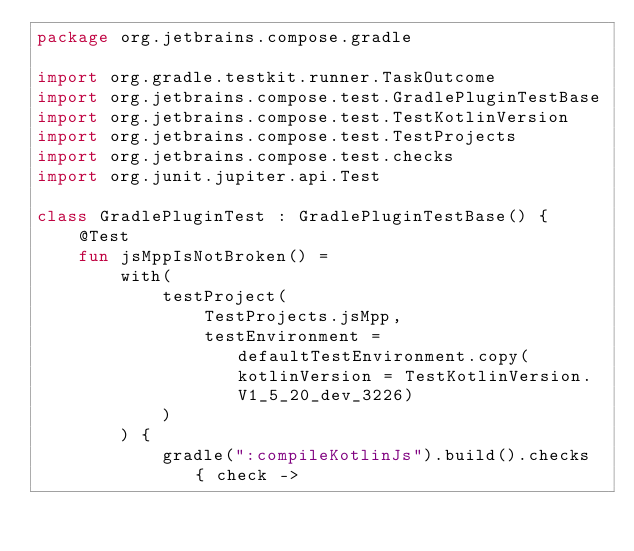Convert code to text. <code><loc_0><loc_0><loc_500><loc_500><_Kotlin_>package org.jetbrains.compose.gradle

import org.gradle.testkit.runner.TaskOutcome
import org.jetbrains.compose.test.GradlePluginTestBase
import org.jetbrains.compose.test.TestKotlinVersion
import org.jetbrains.compose.test.TestProjects
import org.jetbrains.compose.test.checks
import org.junit.jupiter.api.Test

class GradlePluginTest : GradlePluginTestBase() {
    @Test
    fun jsMppIsNotBroken() =
        with(
            testProject(
                TestProjects.jsMpp,
                testEnvironment = defaultTestEnvironment.copy(kotlinVersion = TestKotlinVersion.V1_5_20_dev_3226)
            )
        ) {
            gradle(":compileKotlinJs").build().checks { check -></code> 